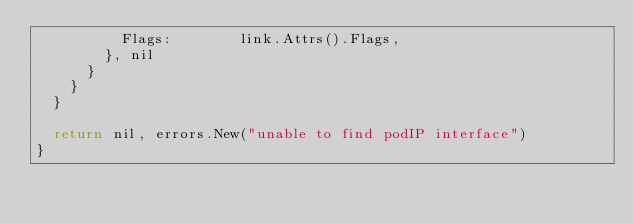Convert code to text. <code><loc_0><loc_0><loc_500><loc_500><_Go_>					Flags:        link.Attrs().Flags,
				}, nil
			}
		}
	}

	return nil, errors.New("unable to find podIP interface")
}
</code> 